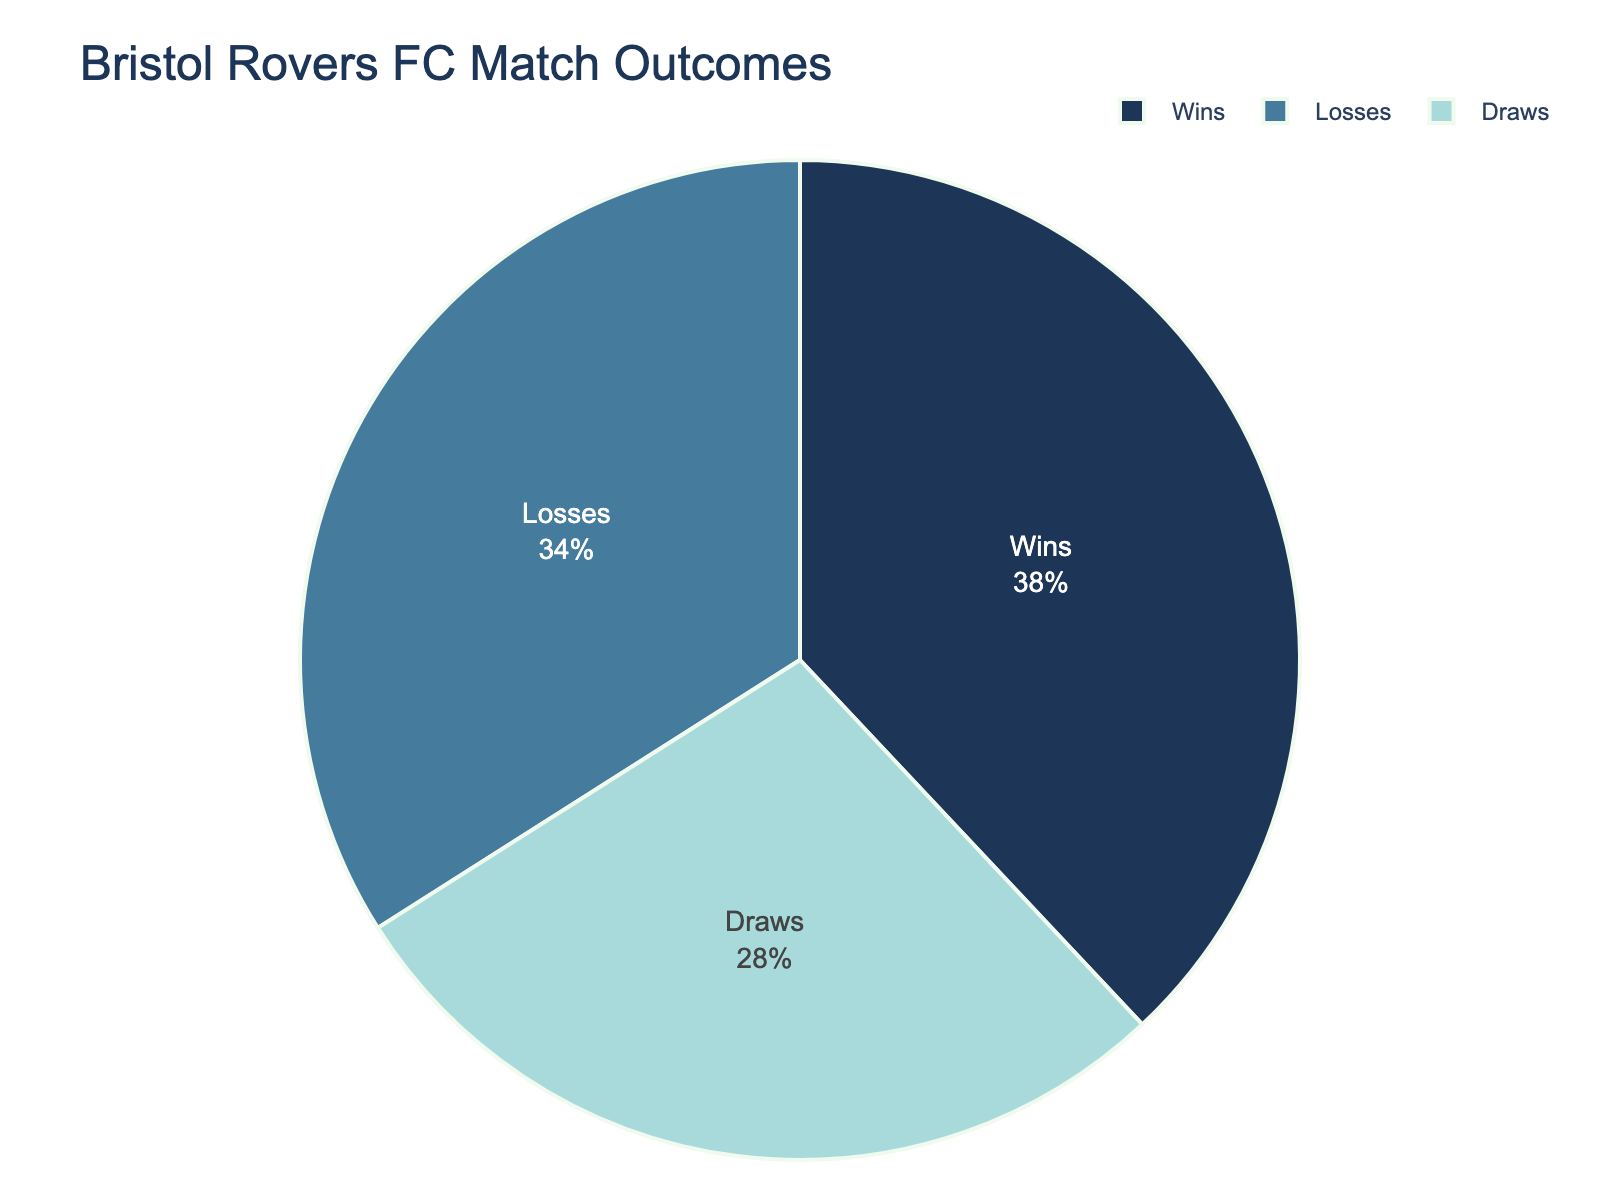What percentage of Bristol Rovers FC’s matches ended in wins? The pie chart shows the percentage split of match outcomes. Locate the segment labeled "Wins" to find the percentage.
Answer: 38% How does the percentage of draws compare to the percentage of losses? Check the segments labeled "Draws" and "Losses" on the pie chart. "Draws" is 28% and "Losses" is 34%. Compare these percentages directly.
Answer: Draws are 6% less than losses What is the combined percentage of matches that didn't end in a win? Add the percentages of draws and losses from the pie chart. "Draws" is 28% and "Losses" is 34%. So, 28% + 34% = 62%.
Answer: 62% Which match outcome has the smallest percentage, and what is it? Identify the segment with the smallest percentage on the pie chart.
Answer: Draws, 28% If Bristol Rovers play 100 matches in a season, how many matches are expected to end in a win? Use the percentage of wins from the pie chart (38%) and apply it to 100 matches. So, 38% of 100 matches = 38 matches.
Answer: 38 matches How many more matches ended in losses compared to draws in percentage terms? Subtract the percentage of draws from the percentage of losses. Losses: 34%, Draws: 28%. So, 34% - 28% = 6%.
Answer: 6% Are the percentages for wins and losses similar? Compare the percentages for wins (38%) and losses (34%).
Answer: Yes, they are similar What fraction of the matches resulted in either wins or losses? Add the percentages of wins and losses, then convert the total percentage into a fraction. Wins: 38%, Losses: 34%. So, 38% + 34% = 72%. The fraction is 72/100 or 18/25 in simplified form.
Answer: 18/25 Which segment is colored light blue, and what percentage does it represent? Identify the segment colored light blue in the pie chart and note its label and percentage.
Answer: Draws, 28% If the team aims to increase their wins by 5%, what will be the new percentage of wins? Add 5% to the current percentage of wins provided in the pie chart. Current wins: 38%, so 38% + 5% = 43%.
Answer: 43% 